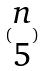<formula> <loc_0><loc_0><loc_500><loc_500>( \begin{matrix} n \\ 5 \end{matrix} )</formula> 